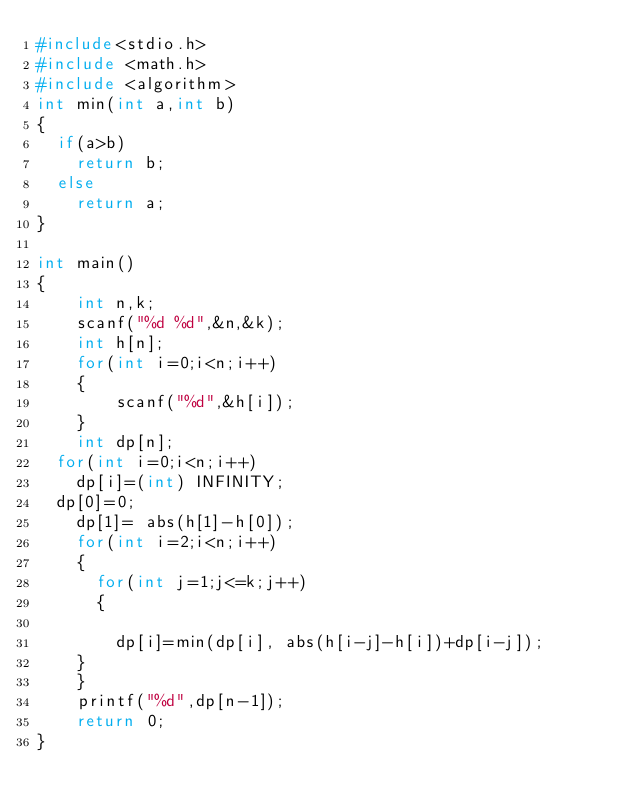<code> <loc_0><loc_0><loc_500><loc_500><_C_>#include<stdio.h>
#include <math.h>
#include <algorithm>
int min(int a,int b)
{
  if(a>b)
    return b;
  else 
    return a;
}
 
int main()
{
    int n,k;
    scanf("%d %d",&n,&k);
    int h[n];
    for(int i=0;i<n;i++)
    {
        scanf("%d",&h[i]);
    }
    int dp[n];
  for(int i=0;i<n;i++)
    dp[i]=(int) INFINITY;
  dp[0]=0;
    dp[1]= abs(h[1]-h[0]);
    for(int i=2;i<n;i++)
    {
      for(int j=1;j<=k;j++)
      {
        
        dp[i]=min(dp[i], abs(h[i-j]-h[i])+dp[i-j]);
    }
    }
    printf("%d",dp[n-1]);
    return 0;
}
</code> 